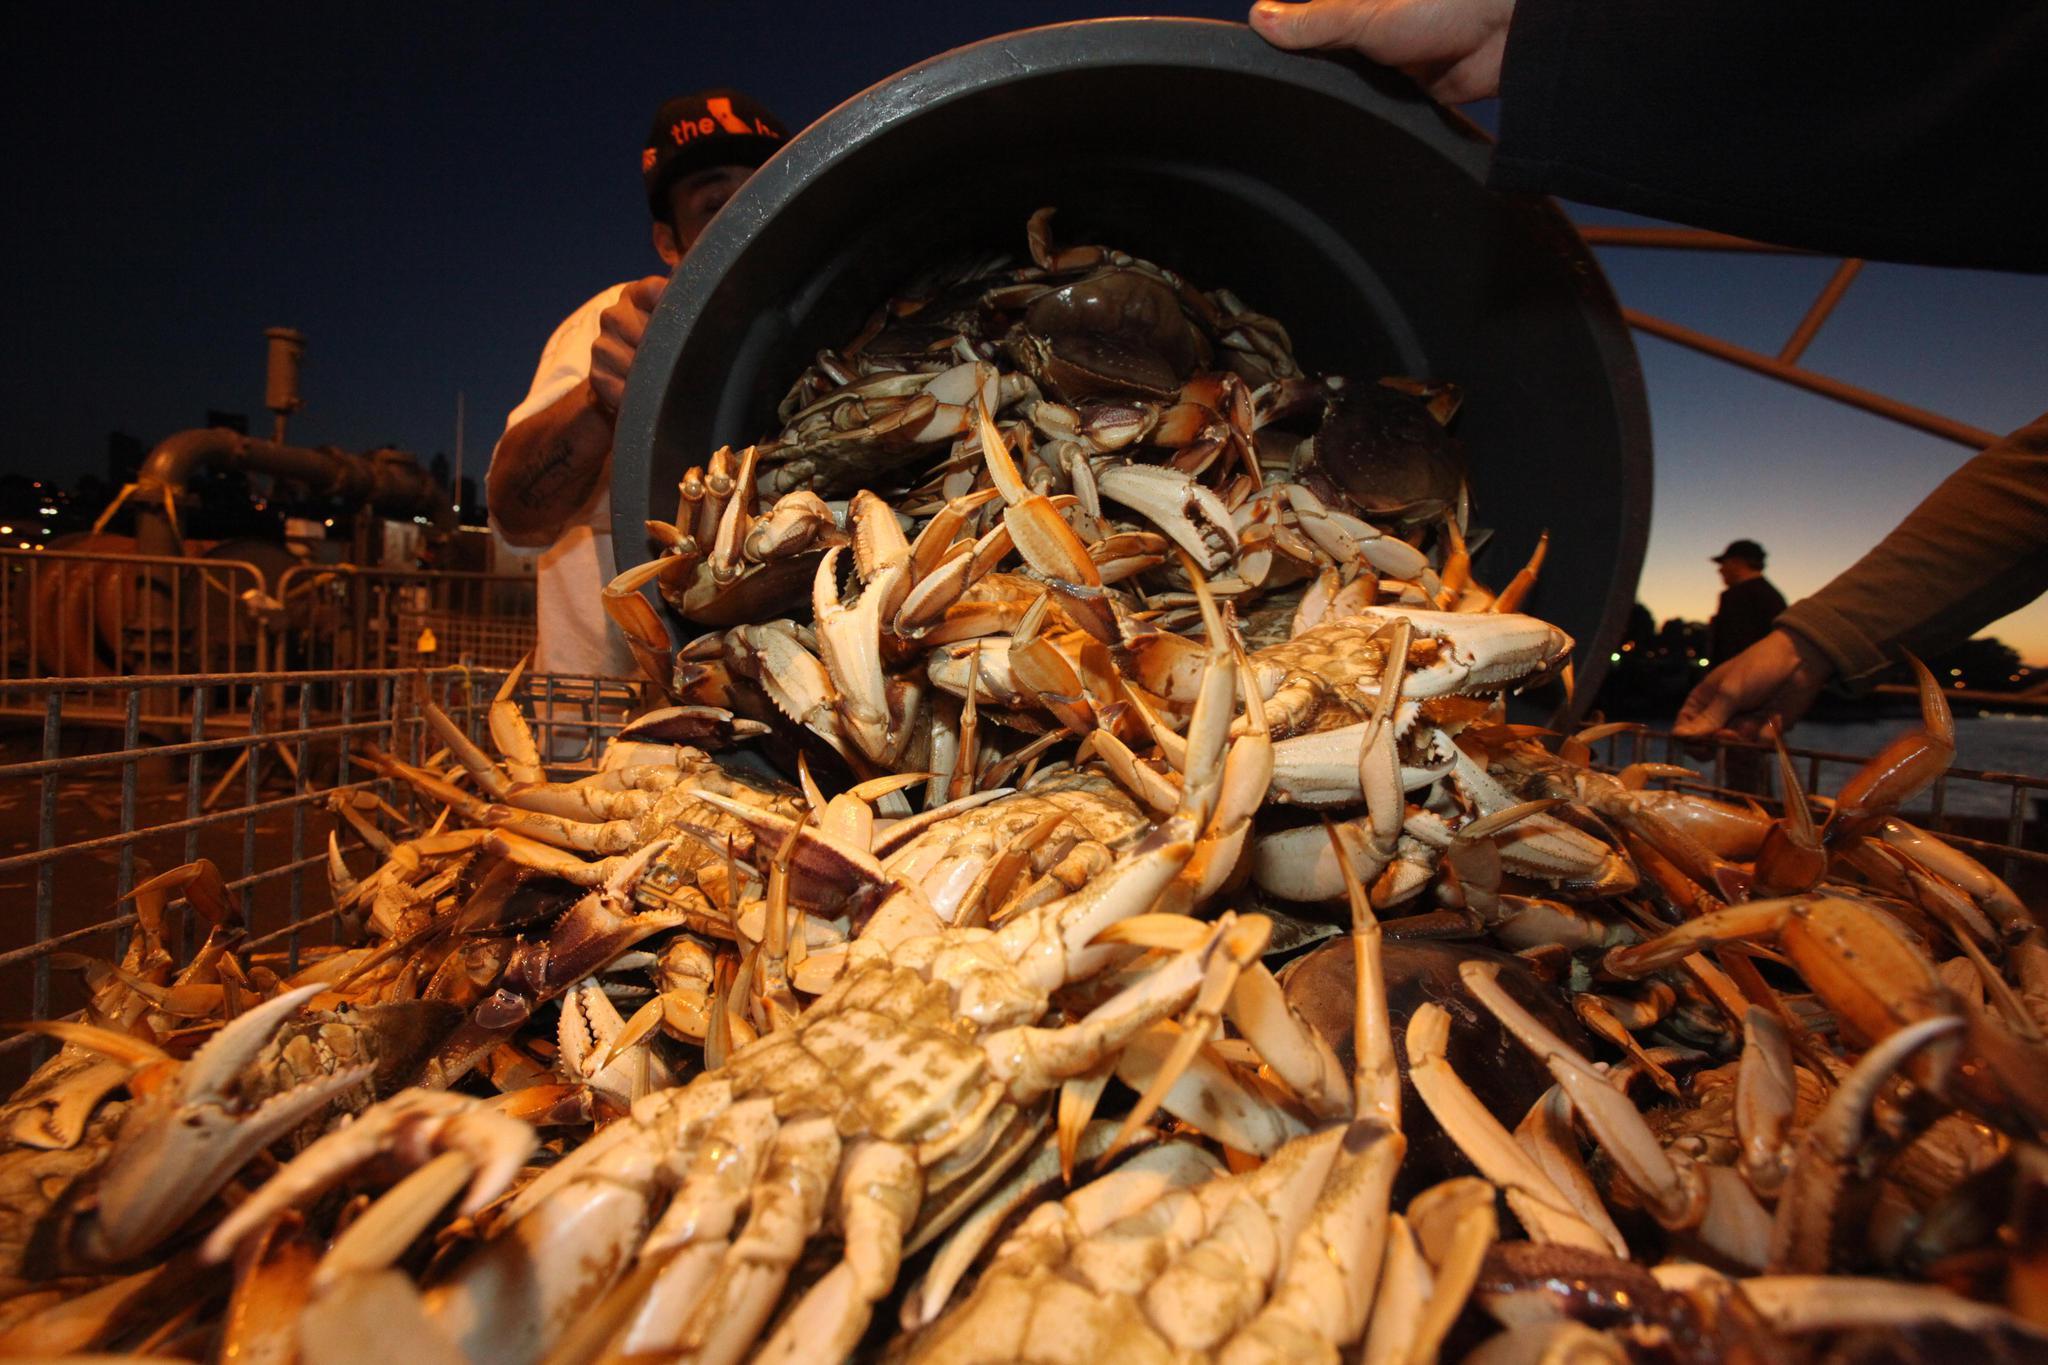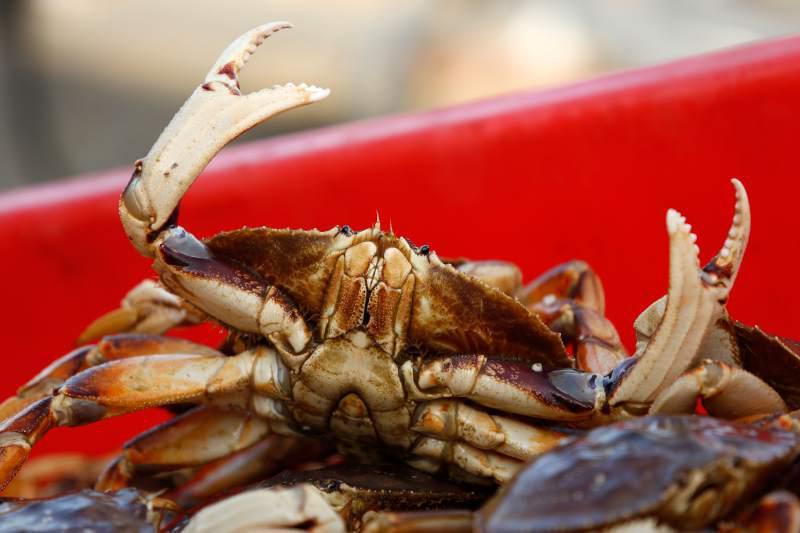The first image is the image on the left, the second image is the image on the right. For the images shown, is this caption "There are at least 8 upside crabs revealing there what soft part underneath." true? Answer yes or no. Yes. The first image is the image on the left, the second image is the image on the right. Given the left and right images, does the statement "One image includes a camera-facing crab with at least one front claw raised and the edge of a red container behind it." hold true? Answer yes or no. Yes. 